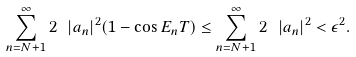<formula> <loc_0><loc_0><loc_500><loc_500>\sum _ { n = N + 1 } ^ { \infty } 2 \ | a _ { n } | ^ { 2 } ( 1 - \cos E _ { n } T ) \leq \sum _ { n = N + 1 } ^ { \infty } 2 \ | a _ { n } | ^ { 2 } < \epsilon ^ { 2 } .</formula> 